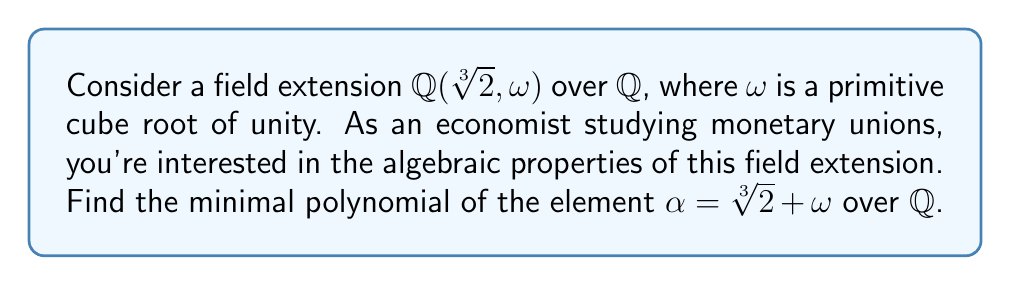Can you solve this math problem? Let's approach this step-by-step:

1) First, recall that $\omega$ satisfies $\omega^2 + \omega + 1 = 0$.

2) Let $f(x)$ be the minimal polynomial of $\alpha$. We know that $\alpha = \sqrt[3]{2} + \omega$.

3) Consider the conjugates of $\alpha$:
   $\alpha_1 = \sqrt[3]{2} + \omega$
   $\alpha_2 = \sqrt[3]{2} + \omega^2$
   $\alpha_3 = \omega\sqrt[3]{2} + 1$
   $\alpha_4 = \omega\sqrt[3]{2} + \omega$
   $\alpha_5 = \omega^2\sqrt[3]{2} + 1$
   $\alpha_6 = \omega^2\sqrt[3]{2} + \omega$

4) The minimal polynomial will be:
   $f(x) = (x - \alpha_1)(x - \alpha_2)(x - \alpha_3)(x - \alpha_4)(x - \alpha_5)(x - \alpha_6)$

5) Expanding this product is complex, but we can simplify by observing that:
   $\alpha_1 + \alpha_2 + \alpha_3 + \alpha_4 + \alpha_5 + \alpha_6 = 2(\sqrt[3]{2} + \omega\sqrt[3]{2} + \omega^2\sqrt[3]{2} + 1 + \omega + \omega^2) = 0$

6) This means that the coefficient of $x^5$ in $f(x)$ is zero.

7) Similarly, we can show that the coefficients of $x^4$, $x^2$, and $x$ are also zero.

8) The constant term will be the product of all roots with a negative sign:
   $-(\sqrt[3]{2} + \omega)(\sqrt[3]{2} + \omega^2)(\omega\sqrt[3]{2} + 1)(\omega\sqrt[3]{2} + \omega)(\omega^2\sqrt[3]{2} + 1)(\omega^2\sqrt[3]{2} + \omega) = -2$

9) The coefficient of $x^3$ can be calculated to be -9.

Therefore, the minimal polynomial of $\alpha$ is $x^6 - 9x^3 - 2$.
Answer: $x^6 - 9x^3 - 2$ 